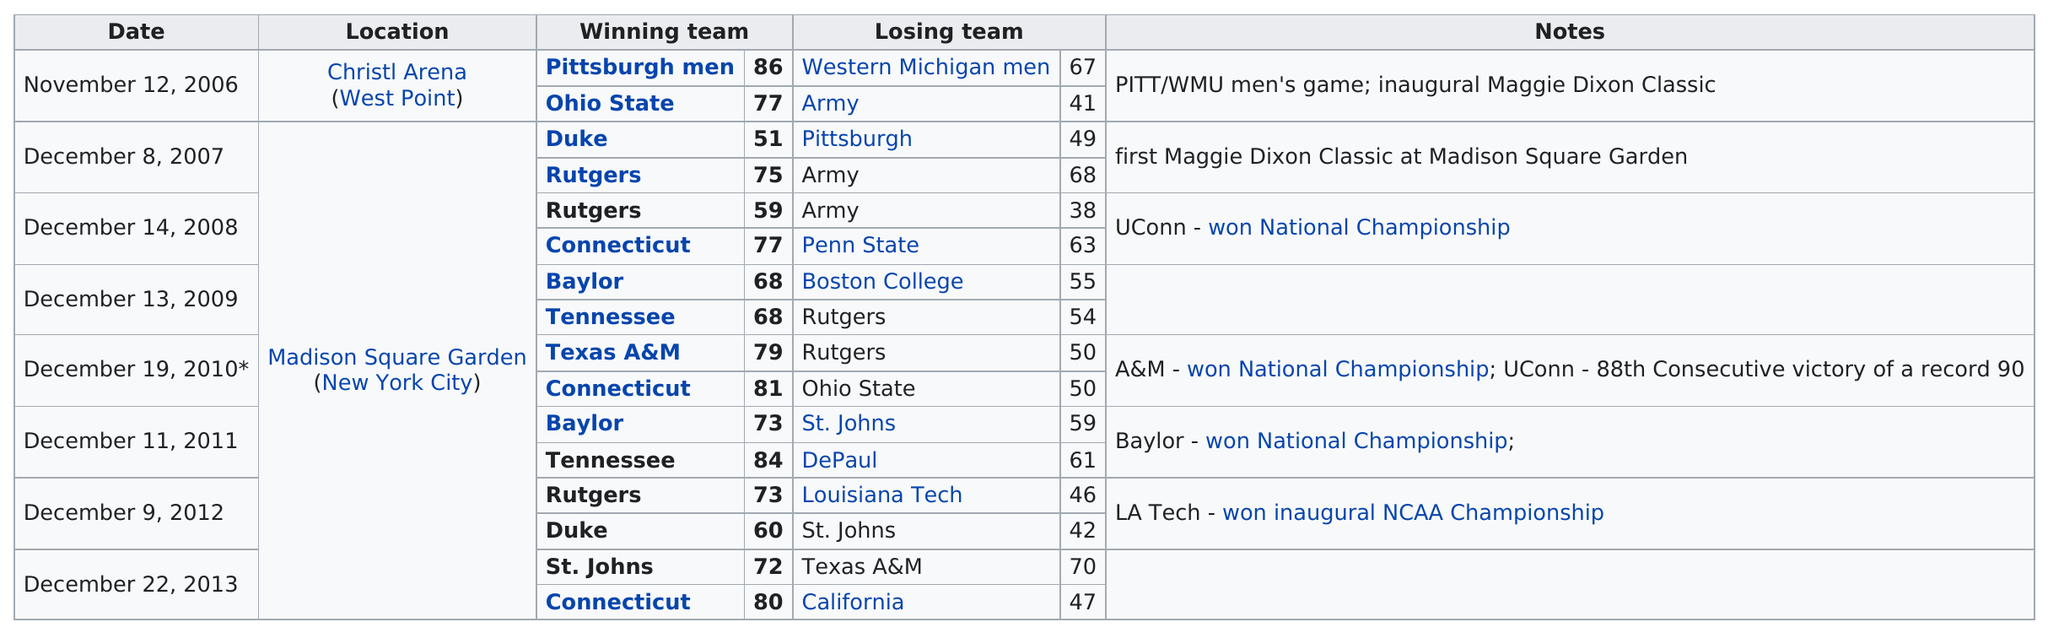Mention a couple of crucial points in this snapshot. The difference between the scores of Ohio State and Army in their 2006 game was 36 points. In the Maggie Dixon Classic, 18 different teams have participated. In total, 14 games were played at Madison Square Garden. Rutgers has played in the classic a total of 5 times. In the 2012 match, Duke or St. John's won? 